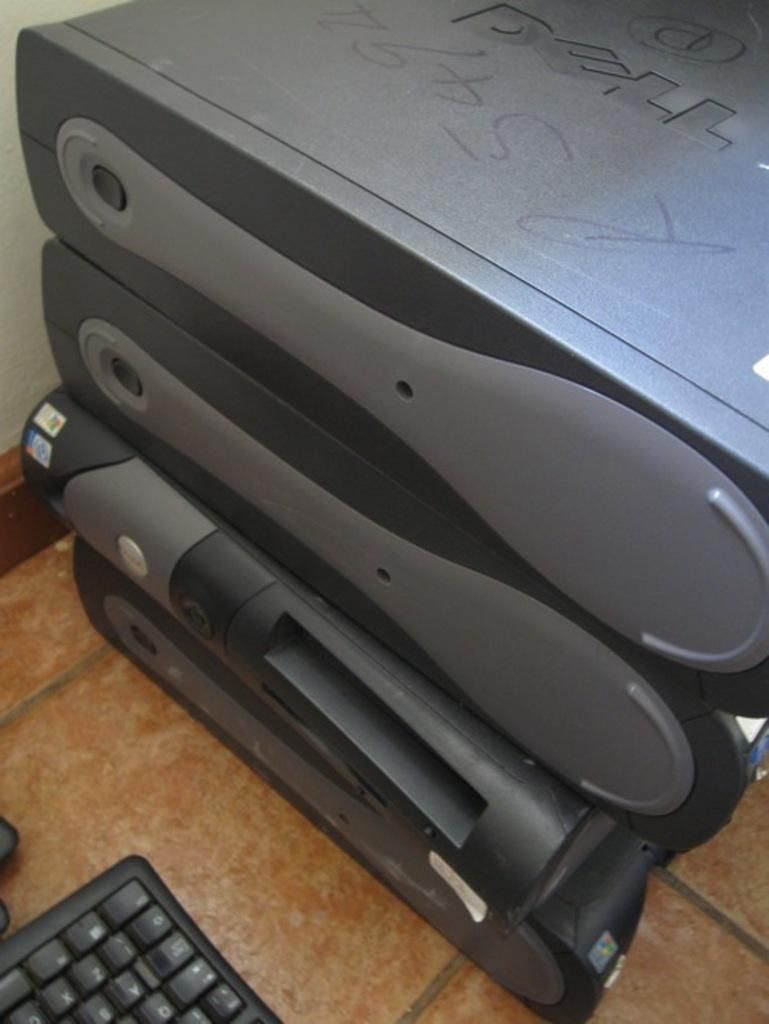<image>
Relay a brief, clear account of the picture shown. a stack of desk top computers by Dell on the tile floor 